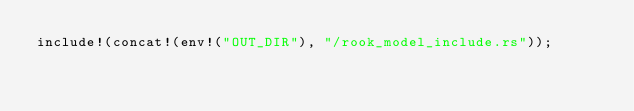<code> <loc_0><loc_0><loc_500><loc_500><_Rust_>include!(concat!(env!("OUT_DIR"), "/rook_model_include.rs"));
</code> 